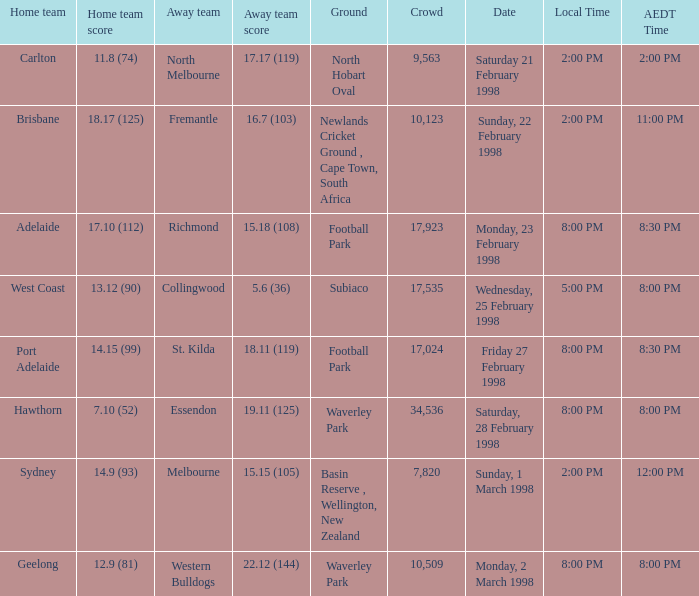Name the AEDT Time which has a Local Time of 8:00 pm, and a Away team score of 22.12 (144)? 8:00 PM. 